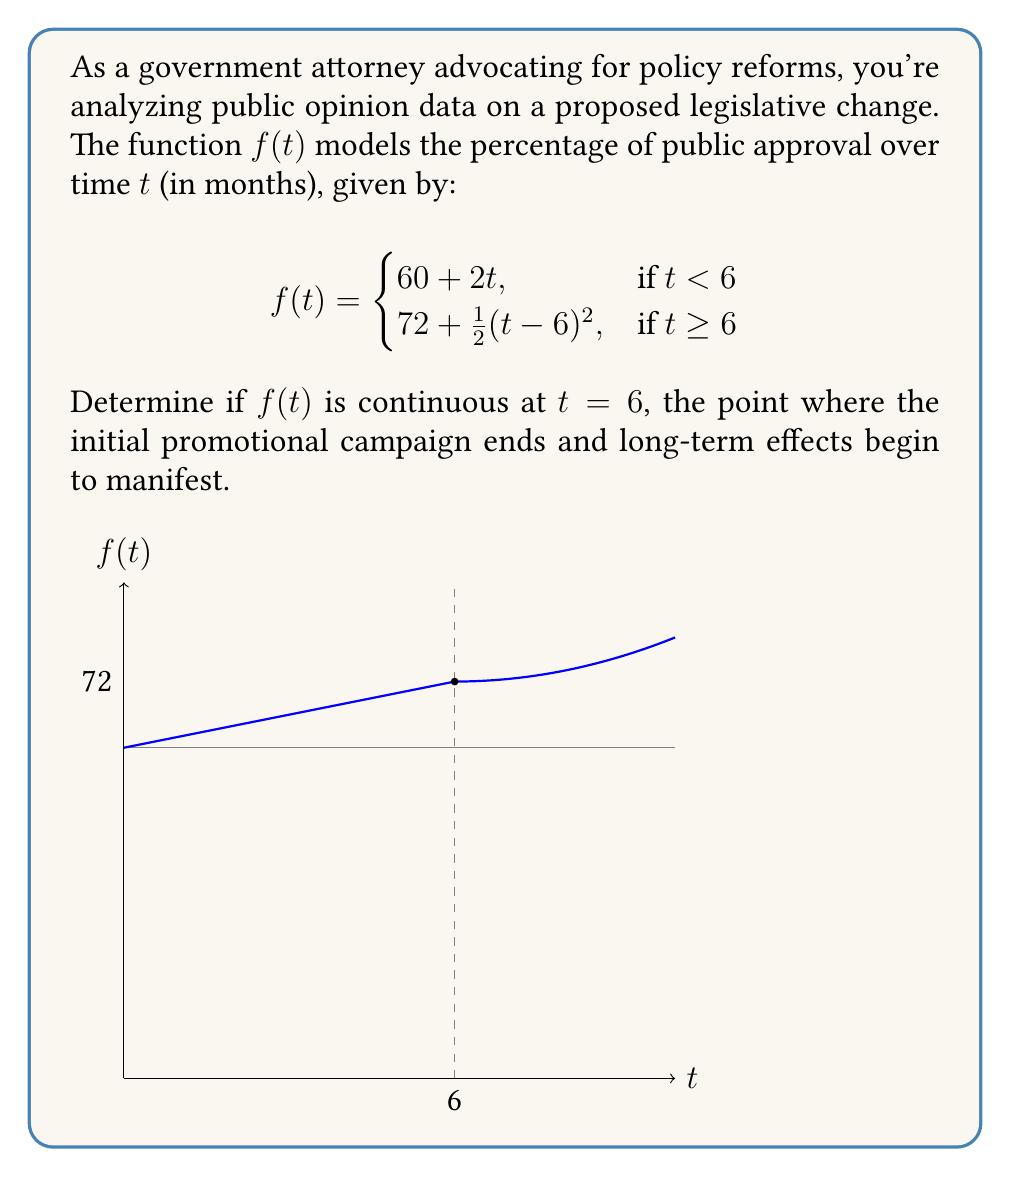Show me your answer to this math problem. To determine if $f(t)$ is continuous at $t = 6$, we need to check three conditions:

1. $f(t)$ is defined at $t = 6$
2. $\lim_{t \to 6^-} f(t)$ exists
3. $\lim_{t \to 6^+} f(t)$ exists
4. $\lim_{t \to 6^-} f(t) = \lim_{t \to 6^+} f(t) = f(6)$

Step 1: Check if $f(6)$ is defined
$f(6) = 72 + \frac{1}{2}(6-6)^2 = 72$, so $f(t)$ is defined at $t = 6$.

Step 2: Calculate $\lim_{t \to 6^-} f(t)$
$$\lim_{t \to 6^-} f(t) = \lim_{t \to 6^-} (60 + 2t) = 60 + 2(6) = 72$$

Step 3: Calculate $\lim_{t \to 6^+} f(t)$
$$\lim_{t \to 6^+} f(t) = \lim_{t \to 6^+} (72 + \frac{1}{2}(t-6)^2) = 72 + \frac{1}{2}(0)^2 = 72$$

Step 4: Verify that all limits are equal to $f(6)$
We see that $\lim_{t \to 6^-} f(t) = \lim_{t \to 6^+} f(t) = f(6) = 72$

Since all three conditions are met, $f(t)$ is continuous at $t = 6$.
Answer: $f(t)$ is continuous at $t = 6$ 